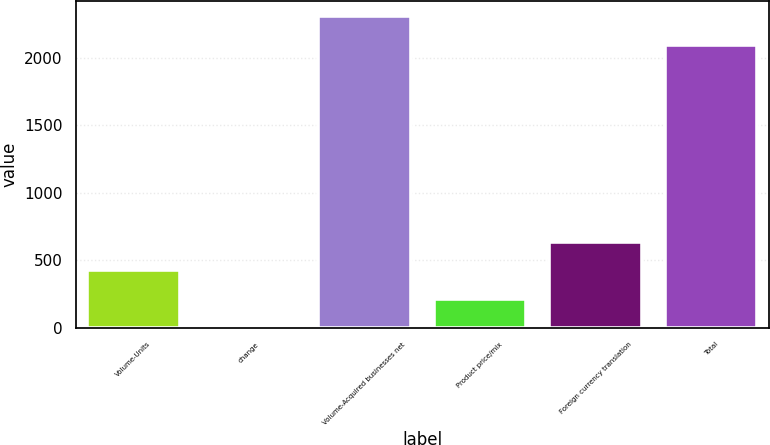<chart> <loc_0><loc_0><loc_500><loc_500><bar_chart><fcel>Volume-Units<fcel>change<fcel>Volume-Acquired businesses net<fcel>Product price/mix<fcel>Foreign currency translation<fcel>Total<nl><fcel>424.96<fcel>1.8<fcel>2308.78<fcel>213.38<fcel>636.54<fcel>2097.2<nl></chart> 